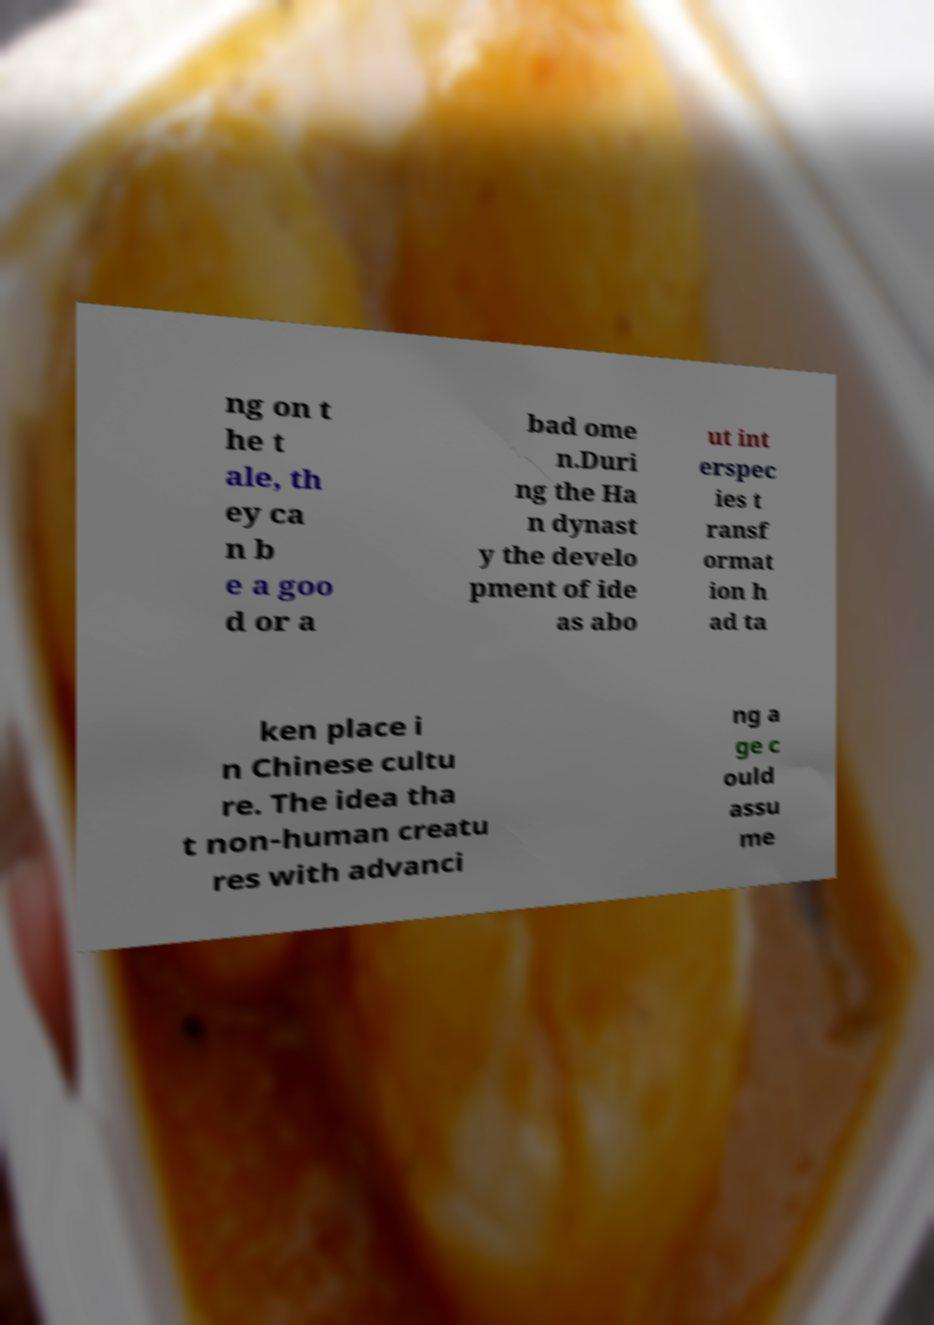Please read and relay the text visible in this image. What does it say? ng on t he t ale, th ey ca n b e a goo d or a bad ome n.Duri ng the Ha n dynast y the develo pment of ide as abo ut int erspec ies t ransf ormat ion h ad ta ken place i n Chinese cultu re. The idea tha t non-human creatu res with advanci ng a ge c ould assu me 